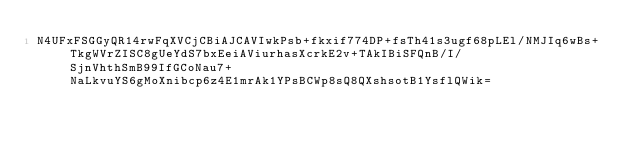Convert code to text. <code><loc_0><loc_0><loc_500><loc_500><_SML_>N4UFxFSGGyQR14rwFqXVCjCBiAJCAVIwkPsb+fkxif774DP+fsTh41s3ugf68pLEl/NMJIq6wBs+TkgWVrZISC8gUeYdS7bxEeiAViurhasXcrkE2v+TAkIBiSFQnB/I/SjnVhthSmB99IfGCoNau7+NaLkvuYS6gMoXnibcp6z4E1mrAk1YPsBCWp8sQ8QXshsotB1YsflQWik=</code> 